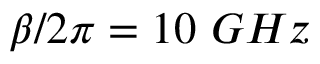Convert formula to latex. <formula><loc_0><loc_0><loc_500><loc_500>\beta / 2 \pi = 1 0 G H z</formula> 